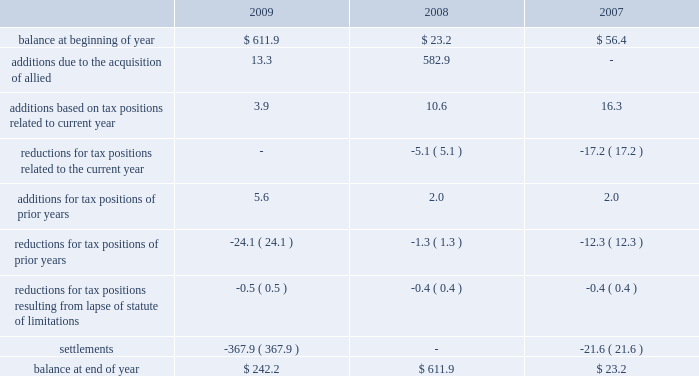The table summarizes the activity in our gross unrecognized tax benefits for the years ended december 31: .
New accounting guidance for business combinations is effective for our 2009 financial statements .
This new guidance significantly changes the treatment of acquired uncertain tax liabilities .
Under previous guidance , changes in acquired uncertain tax liabilities were recognized through goodwill .
Under this new guidance , subsequent changes in acquired unrecognized tax liabilities are recognized through the income tax provision .
As of december 31 , 2009 , $ 211.9 million of the $ 242.2 million of unrecognized tax benefits related to tax positions taken by allied prior to the merger .
Included in the balance at december 31 , 2009 are approximately $ 217.6 million of unrecognized tax benefits ( net of the federal benefit on state issues ) that , if recognized , would affect the effective income tax rate in future periods .
During 2009 , we settled our outstanding tax dispute related to allied 2019s risk management companies ( see 2014 risk management companies ) with both the doj and the irs .
This settlement reduced our gross unrecognized tax benefits by approximately $ 299.6 million .
During 2009 , we also settled with the irs , through an accounting method change , our outstanding tax dispute related to intercompany insurance premiums paid to allied 2019s captive insurance company .
This settlement reduced our gross unrecognized tax benefits by approxi- mately $ 62.6 million .
In addition to these federal matters , we also resolved various state matters that , in the aggregate , reduced our gross unrecognized tax benefits during 2009 by approximately $ 5.8 million .
We recognize interest and penalties as incurred within the provision for income taxes in our consolidated statements of income .
Related to the unrecognized tax benefits previously noted , we accrued interest of $ 24.5 million during 2009 and , in total as of december 31 , 2009 , have recognized a liability for penalties of $ 1.5 million and interest of $ 92.3 million .
During 2008 , we accrued penalties of $ 0.2 million and interest of $ 5.2 million and , in total at december 31 , 2008 , had recognized a liability for penalties of $ 88.1 million and interest of $ 180.0 million .
During 2007 , we accrued interest of $ 0.9 million and , in total at december 31 , 2007 , had recognized a liability for penalties and interest of $ 5.5 million .
The decrease in accrued interest and penalties between 2009 and 2008 was driven mainly by the settlements discussed previously .
However , the current year interest expense increased due to the accrual of a full twelve months of interest expense on allied 2019s acquired uncertain tax positions versus only one month of accrued interest expense recorded in 2008 .
Gross unrecognized tax benefits that we expect to settle in the following twelve months are in the range of $ 10.0 million to $ 20.0 million .
It is reasonably possible that the amount of unrecognized tax benefits will increase or decrease in the next twelve months .
Republic services , inc .
And subsidiaries notes to consolidated financial statements , continued .
As of december 31 , 2009 , what was the percent unrecognized tax benefits related to tax positions taken by allied prior to the merger .? 
Rationale: the percent is the difference in the amounts divide by the earliest amount
Computations: (211.9 / 242.2)
Answer: 0.8749. 